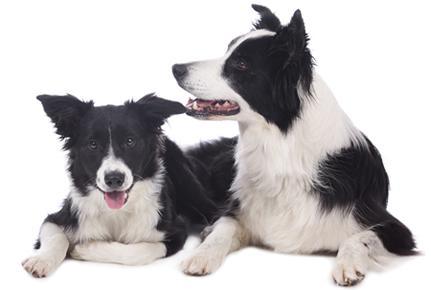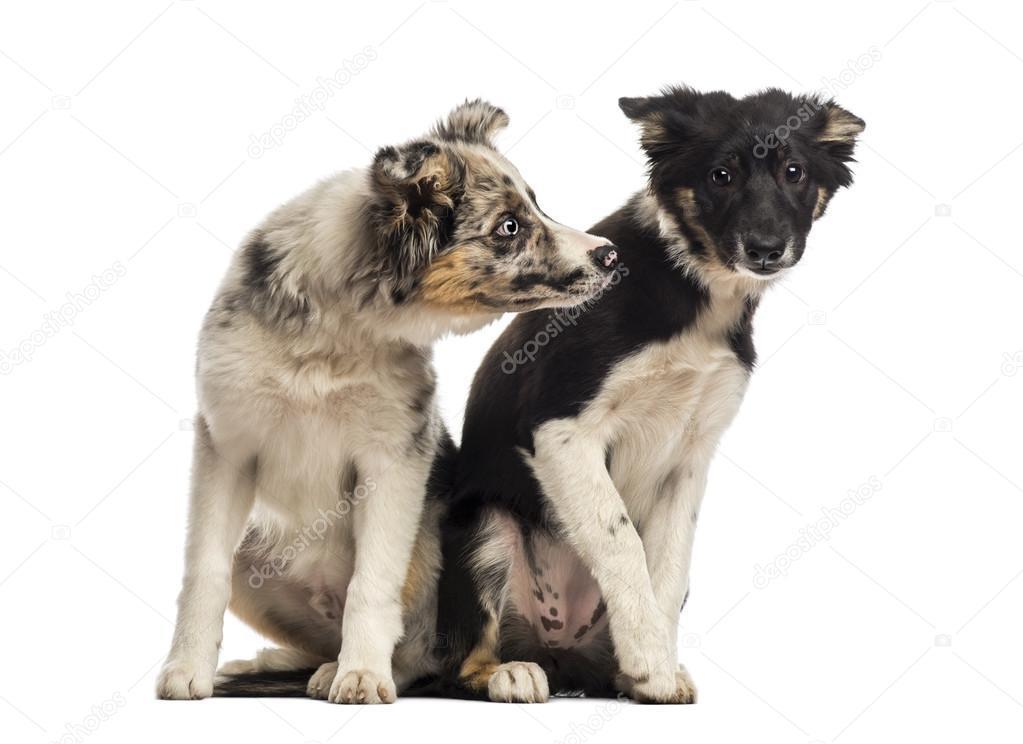The first image is the image on the left, the second image is the image on the right. For the images displayed, is the sentence "The combined images contain three dogs, and in one image, a black-and-white dog sits upright and all alone." factually correct? Answer yes or no. No. The first image is the image on the left, the second image is the image on the right. Analyze the images presented: Is the assertion "There is exactly two dogs in the right image." valid? Answer yes or no. Yes. 